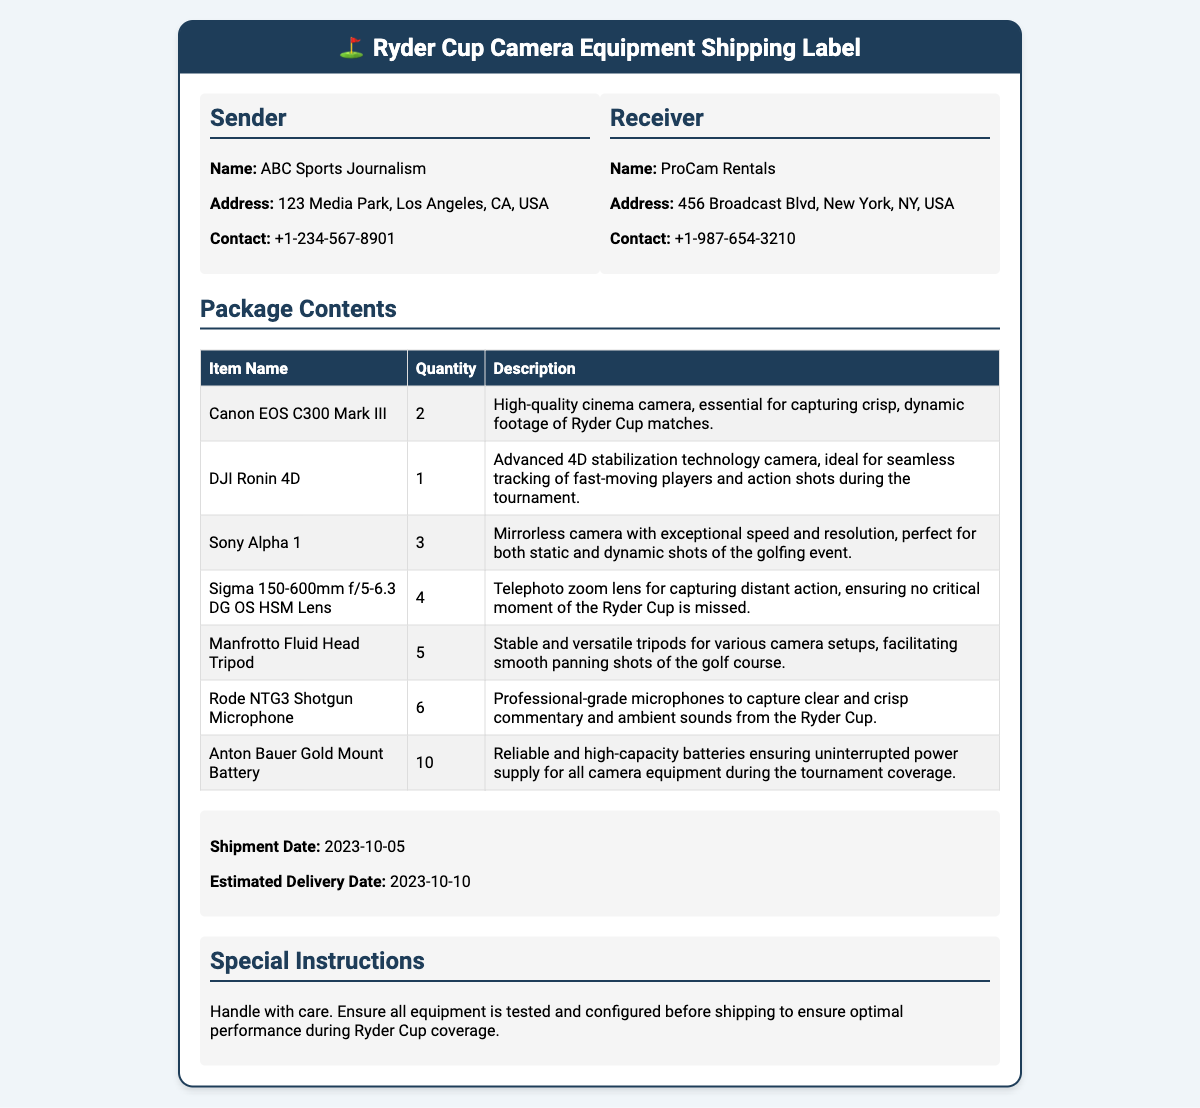What is the sender's name? The sender's name is listed as ABC Sports Journalism in the document.
Answer: ABC Sports Journalism How many Sony Alpha 1 cameras are included? The document specifies that there are three Sony Alpha 1 cameras in the package contents.
Answer: 3 What is the shipment date? The shipment date is provided in the document as the starting date for shipping the equipment.
Answer: 2023-10-05 What type of battery is included? The document specifies the type of battery as Anton Bauer Gold Mount Battery.
Answer: Anton Bauer Gold Mount Battery How many Rode NTG3 Shotgun Microphones are included? The document states there are six Rode NTG3 Shotgun Microphones in the package contents.
Answer: 6 What is the receiver's contact number? The contact number for the receiver is listed as +1-987-654-3210 in the document.
Answer: +1-987-654-3210 What is the estimated delivery date? The document clearly states the estimated delivery date for the shipment.
Answer: 2023-10-10 What is the special instruction regarding the equipment? The special instruction advises to handle the equipment with care.
Answer: Handle with care 